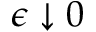Convert formula to latex. <formula><loc_0><loc_0><loc_500><loc_500>\epsilon \downarrow 0</formula> 